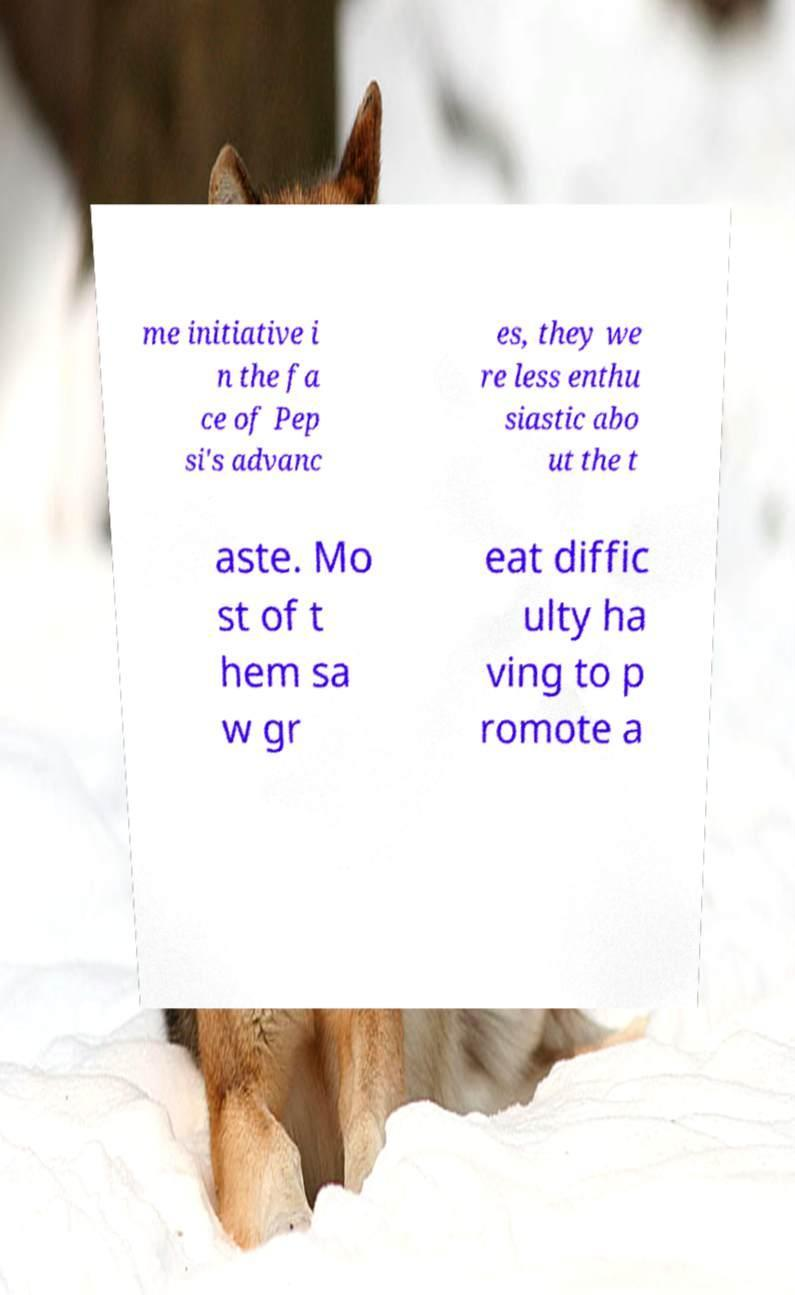Could you assist in decoding the text presented in this image and type it out clearly? me initiative i n the fa ce of Pep si's advanc es, they we re less enthu siastic abo ut the t aste. Mo st of t hem sa w gr eat diffic ulty ha ving to p romote a 